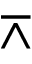Convert formula to latex. <formula><loc_0><loc_0><loc_500><loc_500>\bar { w } e d g e</formula> 